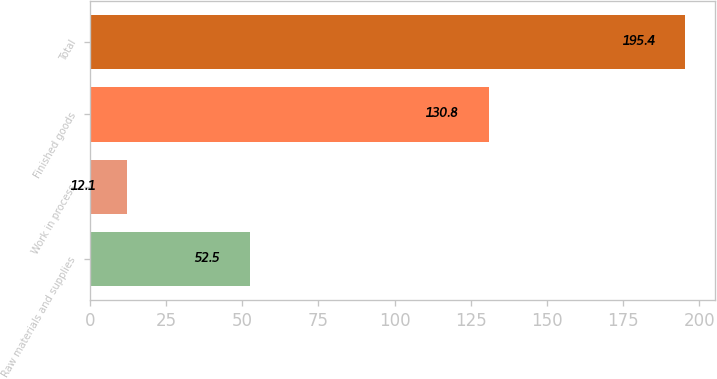<chart> <loc_0><loc_0><loc_500><loc_500><bar_chart><fcel>Raw materials and supplies<fcel>Work in process<fcel>Finished goods<fcel>Total<nl><fcel>52.5<fcel>12.1<fcel>130.8<fcel>195.4<nl></chart> 